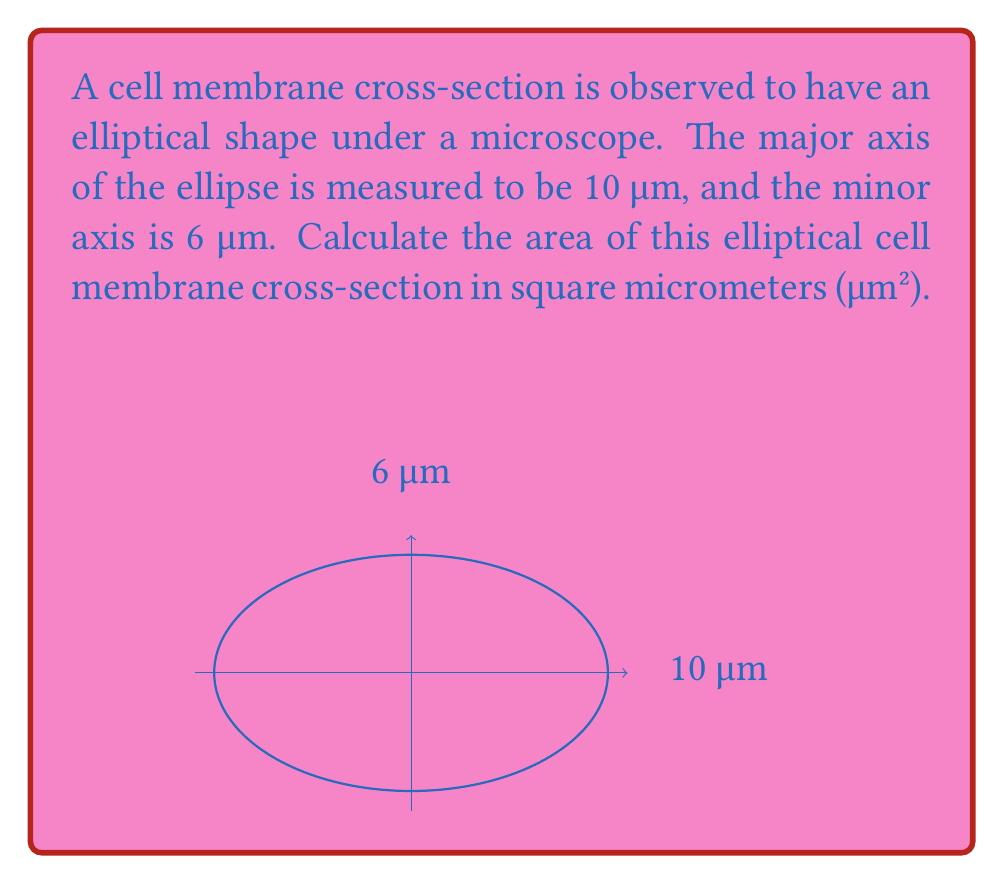Show me your answer to this math problem. To calculate the area of an elliptical cell membrane cross-section, we'll use the formula for the area of an ellipse:

$$A = \pi ab$$

Where:
$A$ = area of the ellipse
$a$ = length of the semi-major axis (half of the major axis)
$b$ = length of the semi-minor axis (half of the minor axis)

Given:
- Major axis = 10 μm
- Minor axis = 6 μm

Step 1: Calculate the semi-major and semi-minor axes
$a = 10 \text{ μm} \div 2 = 5 \text{ μm}$
$b = 6 \text{ μm} \div 2 = 3 \text{ μm}$

Step 2: Apply the formula for the area of an ellipse
$$A = \pi ab$$
$$A = \pi (5 \text{ μm})(3 \text{ μm})$$
$$A = 15\pi \text{ μm}^2$$

Step 3: Calculate the final value (rounded to two decimal places)
$$A \approx 47.12 \text{ μm}^2$$

Therefore, the area of the elliptical cell membrane cross-section is approximately 47.12 μm².
Answer: $47.12 \text{ μm}^2$ 